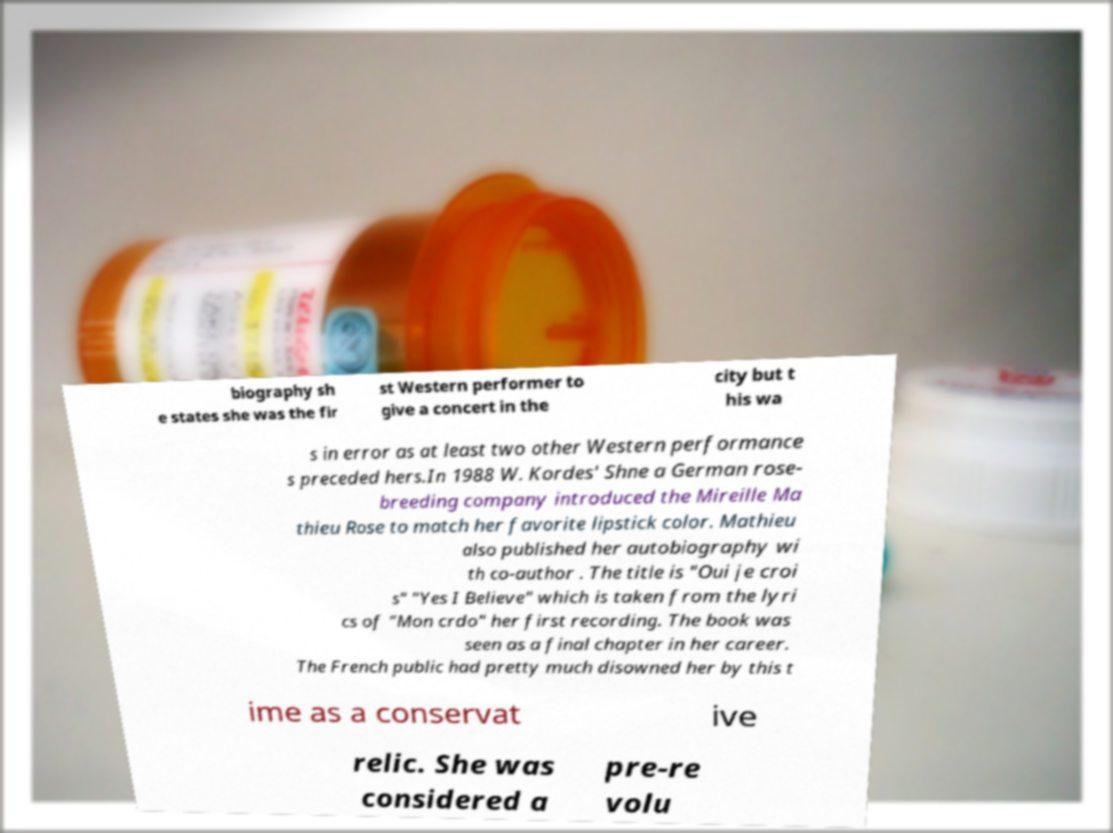For documentation purposes, I need the text within this image transcribed. Could you provide that? biography sh e states she was the fir st Western performer to give a concert in the city but t his wa s in error as at least two other Western performance s preceded hers.In 1988 W. Kordes' Shne a German rose- breeding company introduced the Mireille Ma thieu Rose to match her favorite lipstick color. Mathieu also published her autobiography wi th co-author . The title is "Oui je croi s" "Yes I Believe" which is taken from the lyri cs of "Mon crdo" her first recording. The book was seen as a final chapter in her career. The French public had pretty much disowned her by this t ime as a conservat ive relic. She was considered a pre-re volu 